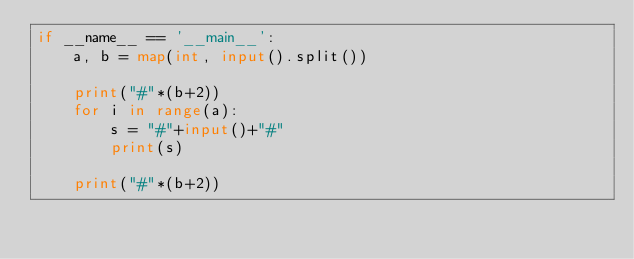Convert code to text. <code><loc_0><loc_0><loc_500><loc_500><_Python_>if __name__ == '__main__':
    a, b = map(int, input().split())

    print("#"*(b+2))
    for i in range(a):
        s = "#"+input()+"#"
        print(s)

    print("#"*(b+2))


</code> 